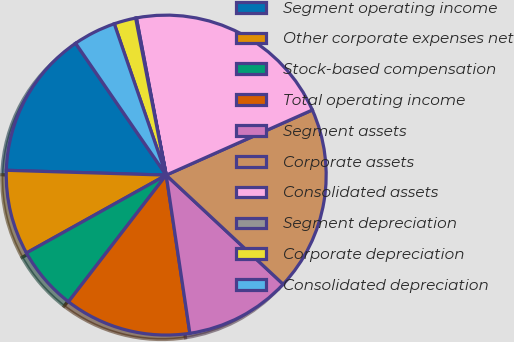Convert chart to OTSL. <chart><loc_0><loc_0><loc_500><loc_500><pie_chart><fcel>Segment operating income<fcel>Other corporate expenses net<fcel>Stock-based compensation<fcel>Total operating income<fcel>Segment assets<fcel>Corporate assets<fcel>Consolidated assets<fcel>Segment depreciation<fcel>Corporate depreciation<fcel>Consolidated depreciation<nl><fcel>14.94%<fcel>8.57%<fcel>6.45%<fcel>12.82%<fcel>10.69%<fcel>18.62%<fcel>21.31%<fcel>0.08%<fcel>2.2%<fcel>4.32%<nl></chart> 